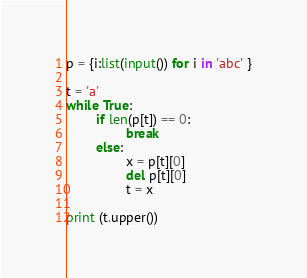Convert code to text. <code><loc_0><loc_0><loc_500><loc_500><_Python_>p = {i:list(input()) for i in 'abc' }

t = 'a'
while True:
        if len(p[t]) == 0:
                break
        else:
                x = p[t][0]
                del p[t][0]
                t = x

print (t.upper())</code> 